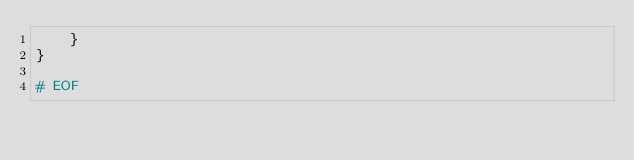<code> <loc_0><loc_0><loc_500><loc_500><_Awk_>    }
}

# EOF
</code> 